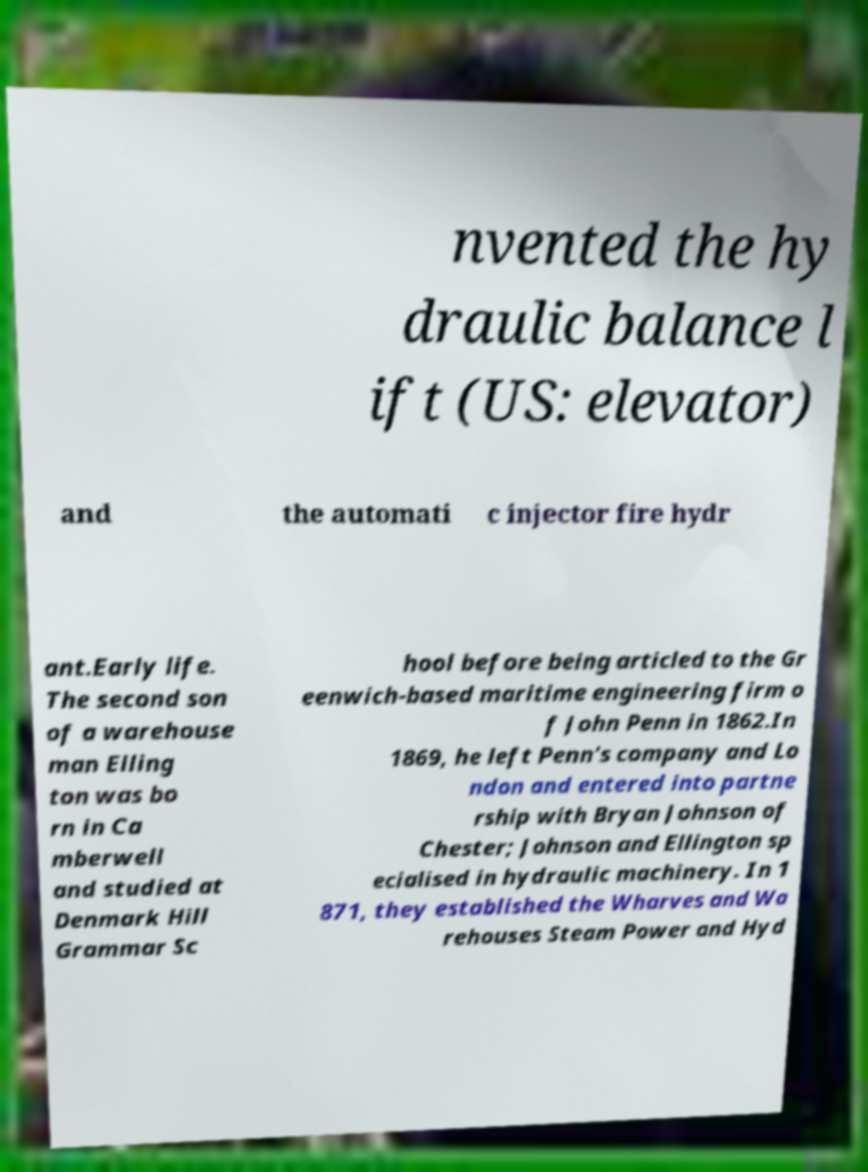For documentation purposes, I need the text within this image transcribed. Could you provide that? nvented the hy draulic balance l ift (US: elevator) and the automati c injector fire hydr ant.Early life. The second son of a warehouse man Elling ton was bo rn in Ca mberwell and studied at Denmark Hill Grammar Sc hool before being articled to the Gr eenwich-based maritime engineering firm o f John Penn in 1862.In 1869, he left Penn's company and Lo ndon and entered into partne rship with Bryan Johnson of Chester; Johnson and Ellington sp ecialised in hydraulic machinery. In 1 871, they established the Wharves and Wa rehouses Steam Power and Hyd 